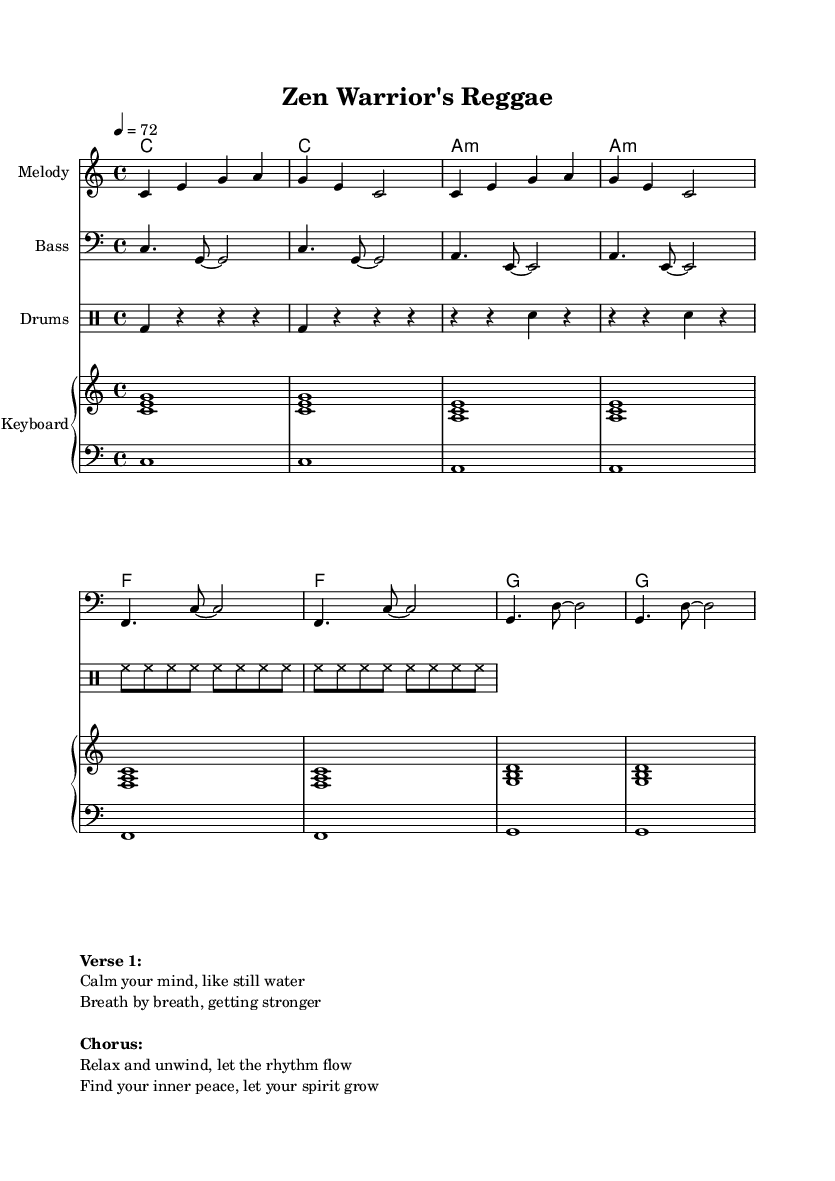What is the key signature of this music? The key signature is C major, indicated by the absence of any sharps or flats at the beginning of the staff.
Answer: C major What is the time signature of this piece? The time signature is 4/4, shown at the beginning of the piece, indicating four beats per measure with a quarter note receiving one beat.
Answer: 4/4 What is the tempo marking in beats per minute? The tempo marking indicates a speed of 72 beats per minute, as denoted in the tempo indication at the beginning of the score.
Answer: 72 Which instrument has a clef that shows a lower pitch? The bass instrument uses a bass clef, which is designed for lower pitches compared to the treble clef used for the melody.
Answer: Bass What are the first three chords in the chord progression? The first three chords listed in the chord progression are C, C, and A minor. These can be found in the chord names section following the chord mode indication.
Answer: C, C, A minor How many measures does the melody consist of? The melody consists of two measures, as indicated by the two sets of notes grouped visually before the next line starts within the melody section.
Answer: 2 measures What do the lyrics express in the chorus? The lyrics in the chorus express relaxation and the idea of finding inner peace, as emphasized in the textual section of the score under "Chorus."
Answer: Relax and unwind 